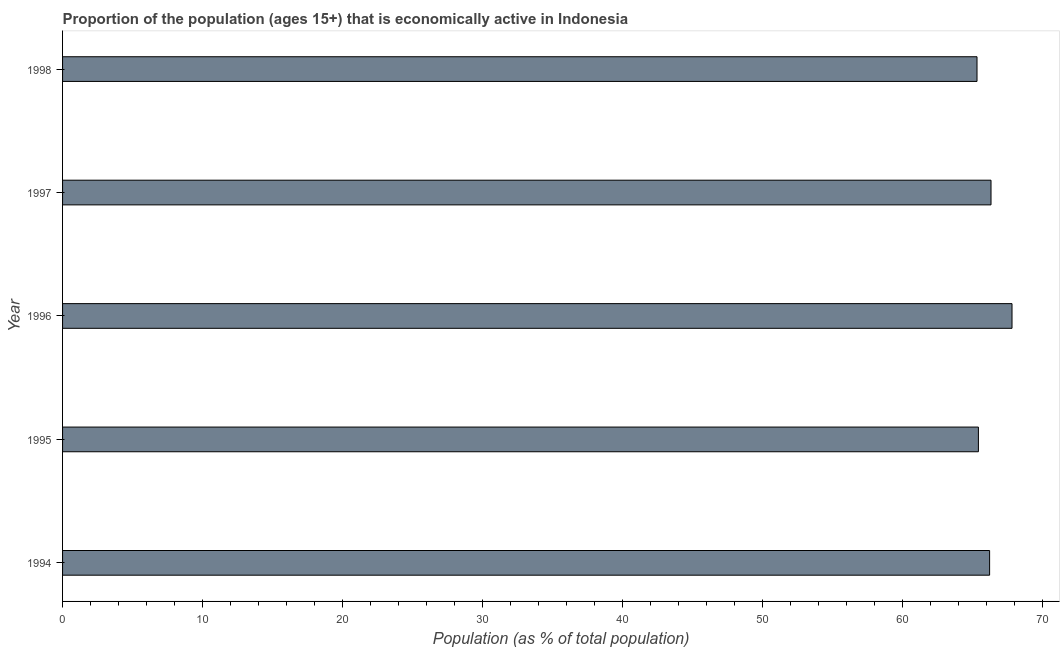Does the graph contain any zero values?
Provide a succinct answer. No. Does the graph contain grids?
Provide a short and direct response. No. What is the title of the graph?
Provide a succinct answer. Proportion of the population (ages 15+) that is economically active in Indonesia. What is the label or title of the X-axis?
Offer a very short reply. Population (as % of total population). What is the percentage of economically active population in 1998?
Make the answer very short. 65.3. Across all years, what is the maximum percentage of economically active population?
Keep it short and to the point. 67.8. Across all years, what is the minimum percentage of economically active population?
Provide a short and direct response. 65.3. In which year was the percentage of economically active population maximum?
Provide a short and direct response. 1996. What is the sum of the percentage of economically active population?
Keep it short and to the point. 331. What is the difference between the percentage of economically active population in 1995 and 1998?
Give a very brief answer. 0.1. What is the average percentage of economically active population per year?
Provide a succinct answer. 66.2. What is the median percentage of economically active population?
Provide a succinct answer. 66.2. What is the ratio of the percentage of economically active population in 1996 to that in 1997?
Your answer should be very brief. 1.02. Is the percentage of economically active population in 1996 less than that in 1998?
Ensure brevity in your answer.  No. In how many years, is the percentage of economically active population greater than the average percentage of economically active population taken over all years?
Make the answer very short. 2. What is the difference between two consecutive major ticks on the X-axis?
Your answer should be very brief. 10. Are the values on the major ticks of X-axis written in scientific E-notation?
Give a very brief answer. No. What is the Population (as % of total population) of 1994?
Keep it short and to the point. 66.2. What is the Population (as % of total population) of 1995?
Give a very brief answer. 65.4. What is the Population (as % of total population) of 1996?
Keep it short and to the point. 67.8. What is the Population (as % of total population) in 1997?
Make the answer very short. 66.3. What is the Population (as % of total population) of 1998?
Offer a terse response. 65.3. What is the difference between the Population (as % of total population) in 1994 and 1995?
Make the answer very short. 0.8. What is the difference between the Population (as % of total population) in 1994 and 1996?
Offer a very short reply. -1.6. What is the difference between the Population (as % of total population) in 1994 and 1997?
Provide a short and direct response. -0.1. What is the difference between the Population (as % of total population) in 1994 and 1998?
Provide a succinct answer. 0.9. What is the difference between the Population (as % of total population) in 1996 and 1998?
Offer a terse response. 2.5. What is the ratio of the Population (as % of total population) in 1994 to that in 1995?
Provide a succinct answer. 1.01. What is the ratio of the Population (as % of total population) in 1994 to that in 1998?
Ensure brevity in your answer.  1.01. What is the ratio of the Population (as % of total population) in 1996 to that in 1997?
Make the answer very short. 1.02. What is the ratio of the Population (as % of total population) in 1996 to that in 1998?
Provide a succinct answer. 1.04. What is the ratio of the Population (as % of total population) in 1997 to that in 1998?
Provide a short and direct response. 1.01. 